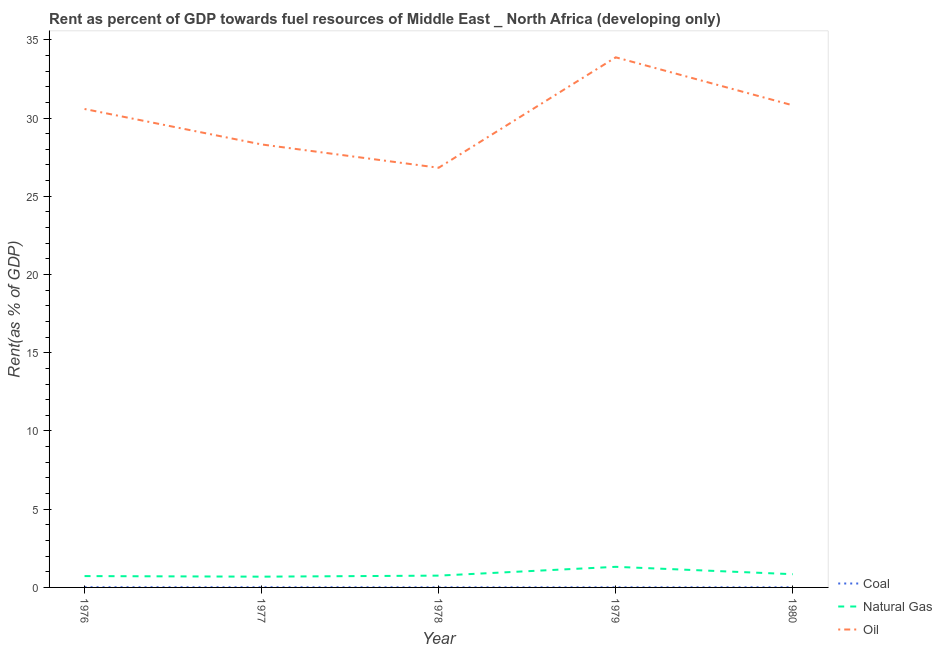How many different coloured lines are there?
Your answer should be very brief. 3. Is the number of lines equal to the number of legend labels?
Provide a short and direct response. Yes. What is the rent towards coal in 1979?
Give a very brief answer. 0.01. Across all years, what is the maximum rent towards oil?
Provide a succinct answer. 33.88. Across all years, what is the minimum rent towards natural gas?
Offer a terse response. 0.69. In which year was the rent towards oil maximum?
Ensure brevity in your answer.  1979. In which year was the rent towards natural gas minimum?
Your response must be concise. 1977. What is the total rent towards oil in the graph?
Make the answer very short. 150.4. What is the difference between the rent towards oil in 1979 and that in 1980?
Provide a succinct answer. 3.07. What is the difference between the rent towards oil in 1979 and the rent towards natural gas in 1978?
Offer a very short reply. 33.12. What is the average rent towards coal per year?
Offer a very short reply. 0.01. In the year 1980, what is the difference between the rent towards oil and rent towards natural gas?
Your response must be concise. 29.97. What is the ratio of the rent towards coal in 1977 to that in 1980?
Your response must be concise. 1.22. Is the rent towards oil in 1976 less than that in 1979?
Your answer should be very brief. Yes. Is the difference between the rent towards oil in 1979 and 1980 greater than the difference between the rent towards coal in 1979 and 1980?
Give a very brief answer. Yes. What is the difference between the highest and the second highest rent towards coal?
Give a very brief answer. 0. What is the difference between the highest and the lowest rent towards natural gas?
Keep it short and to the point. 0.63. In how many years, is the rent towards coal greater than the average rent towards coal taken over all years?
Keep it short and to the point. 2. Is the sum of the rent towards natural gas in 1976 and 1980 greater than the maximum rent towards coal across all years?
Your response must be concise. Yes. Is it the case that in every year, the sum of the rent towards coal and rent towards natural gas is greater than the rent towards oil?
Make the answer very short. No. Does the rent towards coal monotonically increase over the years?
Your response must be concise. No. Does the graph contain any zero values?
Offer a very short reply. No. What is the title of the graph?
Offer a terse response. Rent as percent of GDP towards fuel resources of Middle East _ North Africa (developing only). What is the label or title of the Y-axis?
Your response must be concise. Rent(as % of GDP). What is the Rent(as % of GDP) in Coal in 1976?
Your response must be concise. 0.01. What is the Rent(as % of GDP) of Natural Gas in 1976?
Keep it short and to the point. 0.72. What is the Rent(as % of GDP) in Oil in 1976?
Make the answer very short. 30.58. What is the Rent(as % of GDP) of Coal in 1977?
Give a very brief answer. 0.01. What is the Rent(as % of GDP) in Natural Gas in 1977?
Ensure brevity in your answer.  0.69. What is the Rent(as % of GDP) in Oil in 1977?
Offer a very short reply. 28.31. What is the Rent(as % of GDP) in Coal in 1978?
Provide a succinct answer. 0.01. What is the Rent(as % of GDP) of Natural Gas in 1978?
Give a very brief answer. 0.75. What is the Rent(as % of GDP) in Oil in 1978?
Provide a succinct answer. 26.82. What is the Rent(as % of GDP) in Coal in 1979?
Your answer should be very brief. 0.01. What is the Rent(as % of GDP) in Natural Gas in 1979?
Provide a succinct answer. 1.32. What is the Rent(as % of GDP) of Oil in 1979?
Your answer should be very brief. 33.88. What is the Rent(as % of GDP) in Coal in 1980?
Offer a terse response. 0.01. What is the Rent(as % of GDP) in Natural Gas in 1980?
Provide a short and direct response. 0.85. What is the Rent(as % of GDP) of Oil in 1980?
Offer a very short reply. 30.81. Across all years, what is the maximum Rent(as % of GDP) in Coal?
Offer a very short reply. 0.01. Across all years, what is the maximum Rent(as % of GDP) of Natural Gas?
Give a very brief answer. 1.32. Across all years, what is the maximum Rent(as % of GDP) of Oil?
Your answer should be very brief. 33.88. Across all years, what is the minimum Rent(as % of GDP) in Coal?
Make the answer very short. 0.01. Across all years, what is the minimum Rent(as % of GDP) of Natural Gas?
Ensure brevity in your answer.  0.69. Across all years, what is the minimum Rent(as % of GDP) of Oil?
Make the answer very short. 26.82. What is the total Rent(as % of GDP) in Coal in the graph?
Ensure brevity in your answer.  0.05. What is the total Rent(as % of GDP) of Natural Gas in the graph?
Ensure brevity in your answer.  4.33. What is the total Rent(as % of GDP) of Oil in the graph?
Provide a succinct answer. 150.4. What is the difference between the Rent(as % of GDP) of Coal in 1976 and that in 1977?
Keep it short and to the point. 0. What is the difference between the Rent(as % of GDP) of Natural Gas in 1976 and that in 1977?
Ensure brevity in your answer.  0.04. What is the difference between the Rent(as % of GDP) in Oil in 1976 and that in 1977?
Give a very brief answer. 2.27. What is the difference between the Rent(as % of GDP) in Coal in 1976 and that in 1978?
Make the answer very short. 0.01. What is the difference between the Rent(as % of GDP) in Natural Gas in 1976 and that in 1978?
Your answer should be very brief. -0.03. What is the difference between the Rent(as % of GDP) in Oil in 1976 and that in 1978?
Make the answer very short. 3.76. What is the difference between the Rent(as % of GDP) of Coal in 1976 and that in 1979?
Offer a terse response. 0.01. What is the difference between the Rent(as % of GDP) in Natural Gas in 1976 and that in 1979?
Make the answer very short. -0.59. What is the difference between the Rent(as % of GDP) of Oil in 1976 and that in 1979?
Your answer should be very brief. -3.3. What is the difference between the Rent(as % of GDP) in Coal in 1976 and that in 1980?
Your response must be concise. 0. What is the difference between the Rent(as % of GDP) of Natural Gas in 1976 and that in 1980?
Keep it short and to the point. -0.12. What is the difference between the Rent(as % of GDP) of Oil in 1976 and that in 1980?
Give a very brief answer. -0.23. What is the difference between the Rent(as % of GDP) in Coal in 1977 and that in 1978?
Your response must be concise. 0. What is the difference between the Rent(as % of GDP) in Natural Gas in 1977 and that in 1978?
Your answer should be compact. -0.07. What is the difference between the Rent(as % of GDP) of Oil in 1977 and that in 1978?
Keep it short and to the point. 1.49. What is the difference between the Rent(as % of GDP) in Coal in 1977 and that in 1979?
Offer a terse response. 0. What is the difference between the Rent(as % of GDP) in Natural Gas in 1977 and that in 1979?
Keep it short and to the point. -0.63. What is the difference between the Rent(as % of GDP) of Oil in 1977 and that in 1979?
Your answer should be compact. -5.57. What is the difference between the Rent(as % of GDP) of Coal in 1977 and that in 1980?
Keep it short and to the point. 0. What is the difference between the Rent(as % of GDP) in Natural Gas in 1977 and that in 1980?
Make the answer very short. -0.16. What is the difference between the Rent(as % of GDP) in Oil in 1977 and that in 1980?
Provide a short and direct response. -2.5. What is the difference between the Rent(as % of GDP) in Coal in 1978 and that in 1979?
Give a very brief answer. -0. What is the difference between the Rent(as % of GDP) in Natural Gas in 1978 and that in 1979?
Keep it short and to the point. -0.56. What is the difference between the Rent(as % of GDP) in Oil in 1978 and that in 1979?
Your answer should be compact. -7.06. What is the difference between the Rent(as % of GDP) in Coal in 1978 and that in 1980?
Offer a very short reply. -0. What is the difference between the Rent(as % of GDP) of Natural Gas in 1978 and that in 1980?
Make the answer very short. -0.09. What is the difference between the Rent(as % of GDP) of Oil in 1978 and that in 1980?
Give a very brief answer. -3.99. What is the difference between the Rent(as % of GDP) of Coal in 1979 and that in 1980?
Give a very brief answer. -0. What is the difference between the Rent(as % of GDP) in Natural Gas in 1979 and that in 1980?
Your answer should be compact. 0.47. What is the difference between the Rent(as % of GDP) in Oil in 1979 and that in 1980?
Give a very brief answer. 3.07. What is the difference between the Rent(as % of GDP) in Coal in 1976 and the Rent(as % of GDP) in Natural Gas in 1977?
Your response must be concise. -0.67. What is the difference between the Rent(as % of GDP) in Coal in 1976 and the Rent(as % of GDP) in Oil in 1977?
Offer a very short reply. -28.3. What is the difference between the Rent(as % of GDP) in Natural Gas in 1976 and the Rent(as % of GDP) in Oil in 1977?
Your response must be concise. -27.59. What is the difference between the Rent(as % of GDP) of Coal in 1976 and the Rent(as % of GDP) of Natural Gas in 1978?
Your response must be concise. -0.74. What is the difference between the Rent(as % of GDP) of Coal in 1976 and the Rent(as % of GDP) of Oil in 1978?
Your response must be concise. -26.81. What is the difference between the Rent(as % of GDP) of Natural Gas in 1976 and the Rent(as % of GDP) of Oil in 1978?
Your response must be concise. -26.1. What is the difference between the Rent(as % of GDP) of Coal in 1976 and the Rent(as % of GDP) of Natural Gas in 1979?
Make the answer very short. -1.3. What is the difference between the Rent(as % of GDP) of Coal in 1976 and the Rent(as % of GDP) of Oil in 1979?
Offer a very short reply. -33.87. What is the difference between the Rent(as % of GDP) in Natural Gas in 1976 and the Rent(as % of GDP) in Oil in 1979?
Offer a terse response. -33.15. What is the difference between the Rent(as % of GDP) of Coal in 1976 and the Rent(as % of GDP) of Natural Gas in 1980?
Your answer should be very brief. -0.83. What is the difference between the Rent(as % of GDP) of Coal in 1976 and the Rent(as % of GDP) of Oil in 1980?
Make the answer very short. -30.8. What is the difference between the Rent(as % of GDP) of Natural Gas in 1976 and the Rent(as % of GDP) of Oil in 1980?
Provide a succinct answer. -30.09. What is the difference between the Rent(as % of GDP) in Coal in 1977 and the Rent(as % of GDP) in Natural Gas in 1978?
Your answer should be compact. -0.74. What is the difference between the Rent(as % of GDP) in Coal in 1977 and the Rent(as % of GDP) in Oil in 1978?
Your response must be concise. -26.81. What is the difference between the Rent(as % of GDP) in Natural Gas in 1977 and the Rent(as % of GDP) in Oil in 1978?
Provide a succinct answer. -26.13. What is the difference between the Rent(as % of GDP) of Coal in 1977 and the Rent(as % of GDP) of Natural Gas in 1979?
Keep it short and to the point. -1.3. What is the difference between the Rent(as % of GDP) of Coal in 1977 and the Rent(as % of GDP) of Oil in 1979?
Ensure brevity in your answer.  -33.87. What is the difference between the Rent(as % of GDP) of Natural Gas in 1977 and the Rent(as % of GDP) of Oil in 1979?
Offer a very short reply. -33.19. What is the difference between the Rent(as % of GDP) of Coal in 1977 and the Rent(as % of GDP) of Natural Gas in 1980?
Ensure brevity in your answer.  -0.83. What is the difference between the Rent(as % of GDP) of Coal in 1977 and the Rent(as % of GDP) of Oil in 1980?
Offer a very short reply. -30.8. What is the difference between the Rent(as % of GDP) of Natural Gas in 1977 and the Rent(as % of GDP) of Oil in 1980?
Offer a very short reply. -30.12. What is the difference between the Rent(as % of GDP) in Coal in 1978 and the Rent(as % of GDP) in Natural Gas in 1979?
Provide a short and direct response. -1.31. What is the difference between the Rent(as % of GDP) in Coal in 1978 and the Rent(as % of GDP) in Oil in 1979?
Ensure brevity in your answer.  -33.87. What is the difference between the Rent(as % of GDP) in Natural Gas in 1978 and the Rent(as % of GDP) in Oil in 1979?
Ensure brevity in your answer.  -33.12. What is the difference between the Rent(as % of GDP) in Coal in 1978 and the Rent(as % of GDP) in Natural Gas in 1980?
Give a very brief answer. -0.84. What is the difference between the Rent(as % of GDP) in Coal in 1978 and the Rent(as % of GDP) in Oil in 1980?
Your answer should be compact. -30.8. What is the difference between the Rent(as % of GDP) in Natural Gas in 1978 and the Rent(as % of GDP) in Oil in 1980?
Your answer should be compact. -30.06. What is the difference between the Rent(as % of GDP) in Coal in 1979 and the Rent(as % of GDP) in Natural Gas in 1980?
Your answer should be very brief. -0.84. What is the difference between the Rent(as % of GDP) of Coal in 1979 and the Rent(as % of GDP) of Oil in 1980?
Ensure brevity in your answer.  -30.8. What is the difference between the Rent(as % of GDP) in Natural Gas in 1979 and the Rent(as % of GDP) in Oil in 1980?
Provide a short and direct response. -29.49. What is the average Rent(as % of GDP) in Coal per year?
Ensure brevity in your answer.  0.01. What is the average Rent(as % of GDP) in Natural Gas per year?
Make the answer very short. 0.87. What is the average Rent(as % of GDP) of Oil per year?
Offer a terse response. 30.08. In the year 1976, what is the difference between the Rent(as % of GDP) of Coal and Rent(as % of GDP) of Natural Gas?
Ensure brevity in your answer.  -0.71. In the year 1976, what is the difference between the Rent(as % of GDP) in Coal and Rent(as % of GDP) in Oil?
Make the answer very short. -30.56. In the year 1976, what is the difference between the Rent(as % of GDP) of Natural Gas and Rent(as % of GDP) of Oil?
Give a very brief answer. -29.85. In the year 1977, what is the difference between the Rent(as % of GDP) in Coal and Rent(as % of GDP) in Natural Gas?
Keep it short and to the point. -0.68. In the year 1977, what is the difference between the Rent(as % of GDP) of Coal and Rent(as % of GDP) of Oil?
Your response must be concise. -28.3. In the year 1977, what is the difference between the Rent(as % of GDP) in Natural Gas and Rent(as % of GDP) in Oil?
Keep it short and to the point. -27.62. In the year 1978, what is the difference between the Rent(as % of GDP) in Coal and Rent(as % of GDP) in Natural Gas?
Your answer should be compact. -0.75. In the year 1978, what is the difference between the Rent(as % of GDP) in Coal and Rent(as % of GDP) in Oil?
Make the answer very short. -26.81. In the year 1978, what is the difference between the Rent(as % of GDP) in Natural Gas and Rent(as % of GDP) in Oil?
Your answer should be very brief. -26.07. In the year 1979, what is the difference between the Rent(as % of GDP) in Coal and Rent(as % of GDP) in Natural Gas?
Make the answer very short. -1.31. In the year 1979, what is the difference between the Rent(as % of GDP) of Coal and Rent(as % of GDP) of Oil?
Your answer should be very brief. -33.87. In the year 1979, what is the difference between the Rent(as % of GDP) in Natural Gas and Rent(as % of GDP) in Oil?
Offer a terse response. -32.56. In the year 1980, what is the difference between the Rent(as % of GDP) of Coal and Rent(as % of GDP) of Natural Gas?
Offer a terse response. -0.84. In the year 1980, what is the difference between the Rent(as % of GDP) in Coal and Rent(as % of GDP) in Oil?
Your answer should be compact. -30.8. In the year 1980, what is the difference between the Rent(as % of GDP) of Natural Gas and Rent(as % of GDP) of Oil?
Make the answer very short. -29.97. What is the ratio of the Rent(as % of GDP) of Coal in 1976 to that in 1977?
Provide a succinct answer. 1.12. What is the ratio of the Rent(as % of GDP) in Natural Gas in 1976 to that in 1977?
Give a very brief answer. 1.05. What is the ratio of the Rent(as % of GDP) of Oil in 1976 to that in 1977?
Make the answer very short. 1.08. What is the ratio of the Rent(as % of GDP) in Coal in 1976 to that in 1978?
Make the answer very short. 1.82. What is the ratio of the Rent(as % of GDP) in Natural Gas in 1976 to that in 1978?
Give a very brief answer. 0.96. What is the ratio of the Rent(as % of GDP) in Oil in 1976 to that in 1978?
Ensure brevity in your answer.  1.14. What is the ratio of the Rent(as % of GDP) in Coal in 1976 to that in 1979?
Provide a short and direct response. 1.78. What is the ratio of the Rent(as % of GDP) of Natural Gas in 1976 to that in 1979?
Your response must be concise. 0.55. What is the ratio of the Rent(as % of GDP) in Oil in 1976 to that in 1979?
Your answer should be compact. 0.9. What is the ratio of the Rent(as % of GDP) in Coal in 1976 to that in 1980?
Your response must be concise. 1.37. What is the ratio of the Rent(as % of GDP) of Natural Gas in 1976 to that in 1980?
Offer a terse response. 0.86. What is the ratio of the Rent(as % of GDP) in Oil in 1976 to that in 1980?
Offer a terse response. 0.99. What is the ratio of the Rent(as % of GDP) of Coal in 1977 to that in 1978?
Make the answer very short. 1.62. What is the ratio of the Rent(as % of GDP) in Natural Gas in 1977 to that in 1978?
Your answer should be compact. 0.91. What is the ratio of the Rent(as % of GDP) in Oil in 1977 to that in 1978?
Your answer should be very brief. 1.06. What is the ratio of the Rent(as % of GDP) in Coal in 1977 to that in 1979?
Make the answer very short. 1.59. What is the ratio of the Rent(as % of GDP) in Natural Gas in 1977 to that in 1979?
Your response must be concise. 0.52. What is the ratio of the Rent(as % of GDP) of Oil in 1977 to that in 1979?
Your answer should be compact. 0.84. What is the ratio of the Rent(as % of GDP) of Coal in 1977 to that in 1980?
Provide a succinct answer. 1.22. What is the ratio of the Rent(as % of GDP) in Natural Gas in 1977 to that in 1980?
Keep it short and to the point. 0.81. What is the ratio of the Rent(as % of GDP) in Oil in 1977 to that in 1980?
Give a very brief answer. 0.92. What is the ratio of the Rent(as % of GDP) in Coal in 1978 to that in 1979?
Keep it short and to the point. 0.98. What is the ratio of the Rent(as % of GDP) in Natural Gas in 1978 to that in 1979?
Offer a terse response. 0.57. What is the ratio of the Rent(as % of GDP) of Oil in 1978 to that in 1979?
Offer a very short reply. 0.79. What is the ratio of the Rent(as % of GDP) in Coal in 1978 to that in 1980?
Provide a succinct answer. 0.76. What is the ratio of the Rent(as % of GDP) of Natural Gas in 1978 to that in 1980?
Make the answer very short. 0.89. What is the ratio of the Rent(as % of GDP) in Oil in 1978 to that in 1980?
Your answer should be very brief. 0.87. What is the ratio of the Rent(as % of GDP) of Coal in 1979 to that in 1980?
Give a very brief answer. 0.77. What is the ratio of the Rent(as % of GDP) of Natural Gas in 1979 to that in 1980?
Provide a succinct answer. 1.56. What is the ratio of the Rent(as % of GDP) in Oil in 1979 to that in 1980?
Offer a very short reply. 1.1. What is the difference between the highest and the second highest Rent(as % of GDP) in Coal?
Offer a very short reply. 0. What is the difference between the highest and the second highest Rent(as % of GDP) in Natural Gas?
Your response must be concise. 0.47. What is the difference between the highest and the second highest Rent(as % of GDP) in Oil?
Your answer should be very brief. 3.07. What is the difference between the highest and the lowest Rent(as % of GDP) of Coal?
Keep it short and to the point. 0.01. What is the difference between the highest and the lowest Rent(as % of GDP) in Natural Gas?
Offer a very short reply. 0.63. What is the difference between the highest and the lowest Rent(as % of GDP) in Oil?
Give a very brief answer. 7.06. 